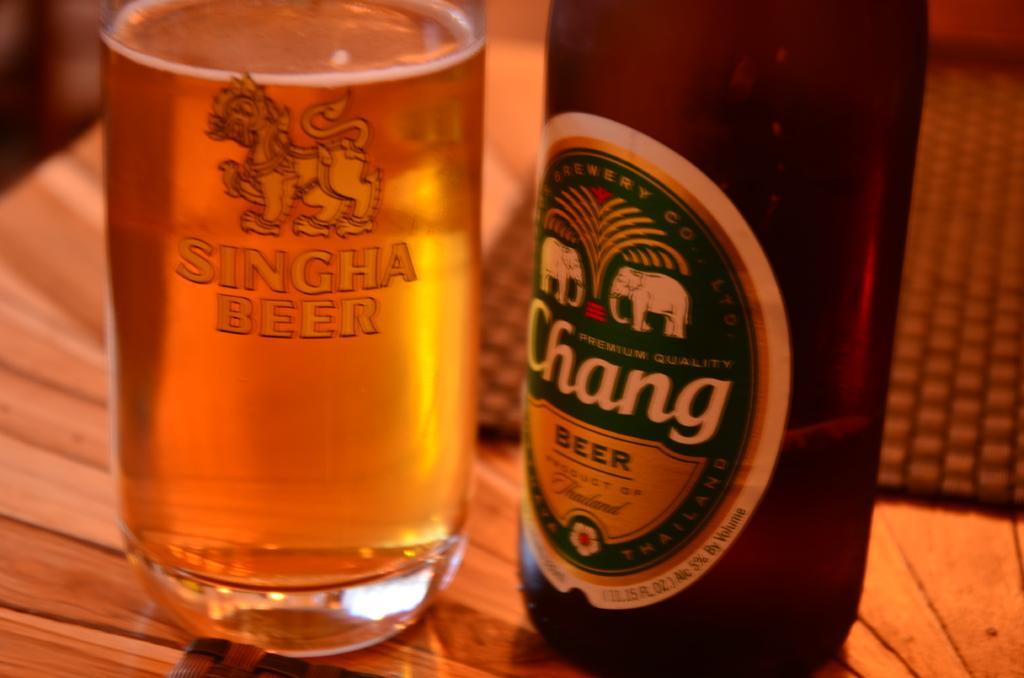In one or two sentences, can you explain what this image depicts? We can see bottles,mat on the table. 